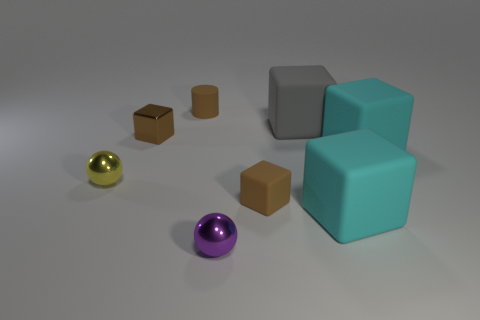Is the matte cylinder the same color as the metallic block?
Ensure brevity in your answer.  Yes. What is the material of the purple object that is the same size as the yellow metallic ball?
Your response must be concise. Metal. Are there any gray shiny cubes of the same size as the gray rubber thing?
Offer a very short reply. No. There is a brown metallic block right of the yellow metallic object; is it the same size as the large gray rubber block?
Your answer should be very brief. No. What shape is the thing that is left of the tiny rubber cylinder and behind the small yellow metallic ball?
Your answer should be very brief. Cube. Is the number of purple things to the left of the tiny yellow shiny ball greater than the number of small green cylinders?
Your answer should be compact. No. There is a brown cylinder that is the same material as the gray cube; what size is it?
Your response must be concise. Small. How many tiny rubber objects have the same color as the metallic block?
Ensure brevity in your answer.  2. There is a sphere to the left of the brown cylinder; does it have the same color as the tiny matte cylinder?
Your response must be concise. No. Are there an equal number of large matte objects that are in front of the gray cube and spheres that are in front of the purple object?
Ensure brevity in your answer.  No. 